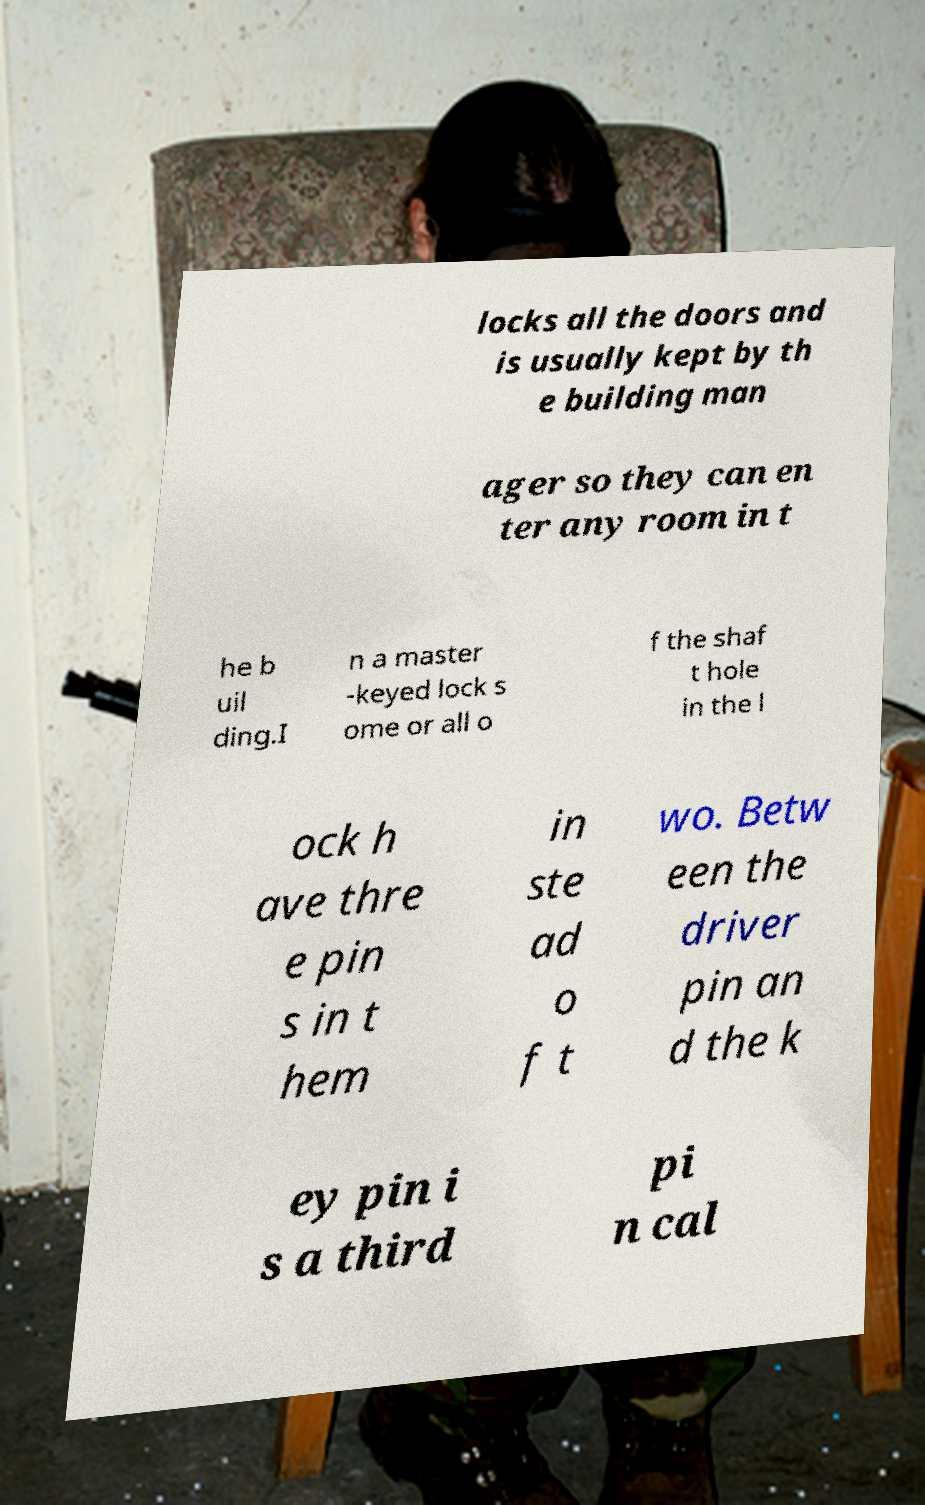Please read and relay the text visible in this image. What does it say? locks all the doors and is usually kept by th e building man ager so they can en ter any room in t he b uil ding.I n a master -keyed lock s ome or all o f the shaf t hole in the l ock h ave thre e pin s in t hem in ste ad o f t wo. Betw een the driver pin an d the k ey pin i s a third pi n cal 